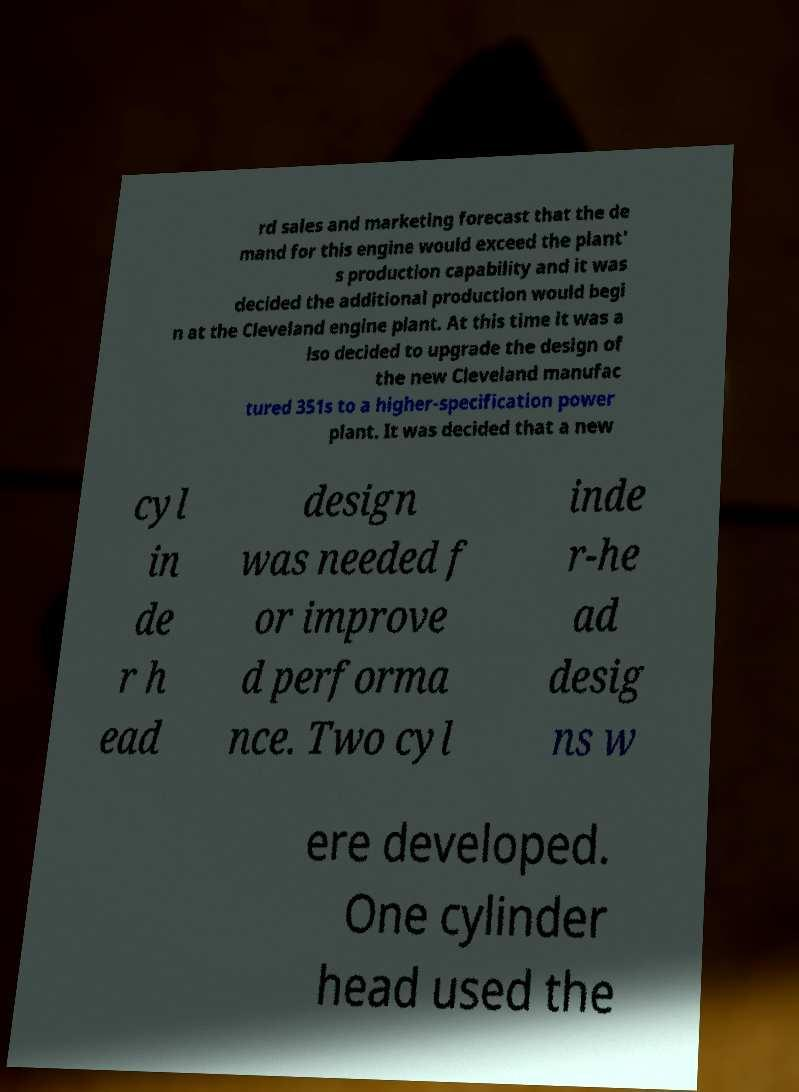Could you extract and type out the text from this image? rd sales and marketing forecast that the de mand for this engine would exceed the plant' s production capability and it was decided the additional production would begi n at the Cleveland engine plant. At this time it was a lso decided to upgrade the design of the new Cleveland manufac tured 351s to a higher-specification power plant. It was decided that a new cyl in de r h ead design was needed f or improve d performa nce. Two cyl inde r-he ad desig ns w ere developed. One cylinder head used the 